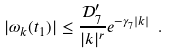<formula> <loc_0><loc_0><loc_500><loc_500>| \omega _ { k } ( t _ { 1 } ) | \leq \frac { \mathcal { D } _ { 7 } ^ { \prime } } { | k | ^ { r } } e ^ { - \gamma _ { 7 } | k | } \ .</formula> 